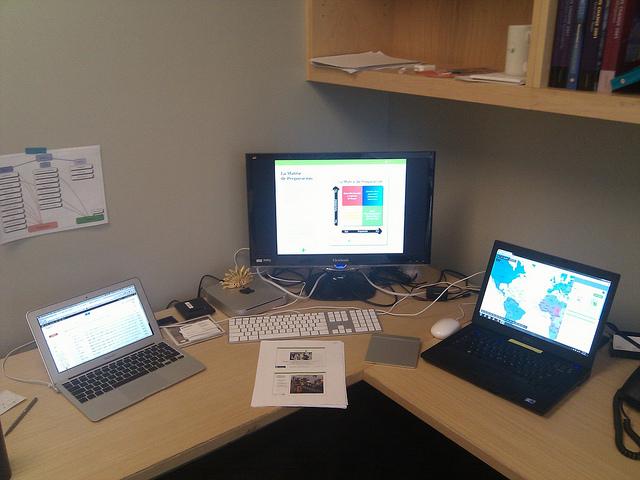What color is the laptop?
Quick response, please. Black. What color is the mouse?
Write a very short answer. White. What do you see in between the laptop and the middle monitor?
Quick response, please. Mouse. How many desktop monitors are shown?
Write a very short answer. 1. How many computers are there?
Concise answer only. 3. How many monitors are shown?
Be succinct. 3. Is there anything on the wall?
Short answer required. Yes. 